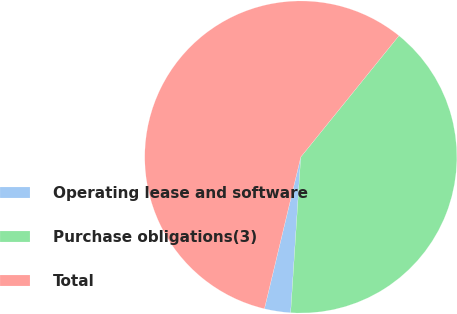Convert chart to OTSL. <chart><loc_0><loc_0><loc_500><loc_500><pie_chart><fcel>Operating lease and software<fcel>Purchase obligations(3)<fcel>Total<nl><fcel>2.71%<fcel>40.21%<fcel>57.09%<nl></chart> 